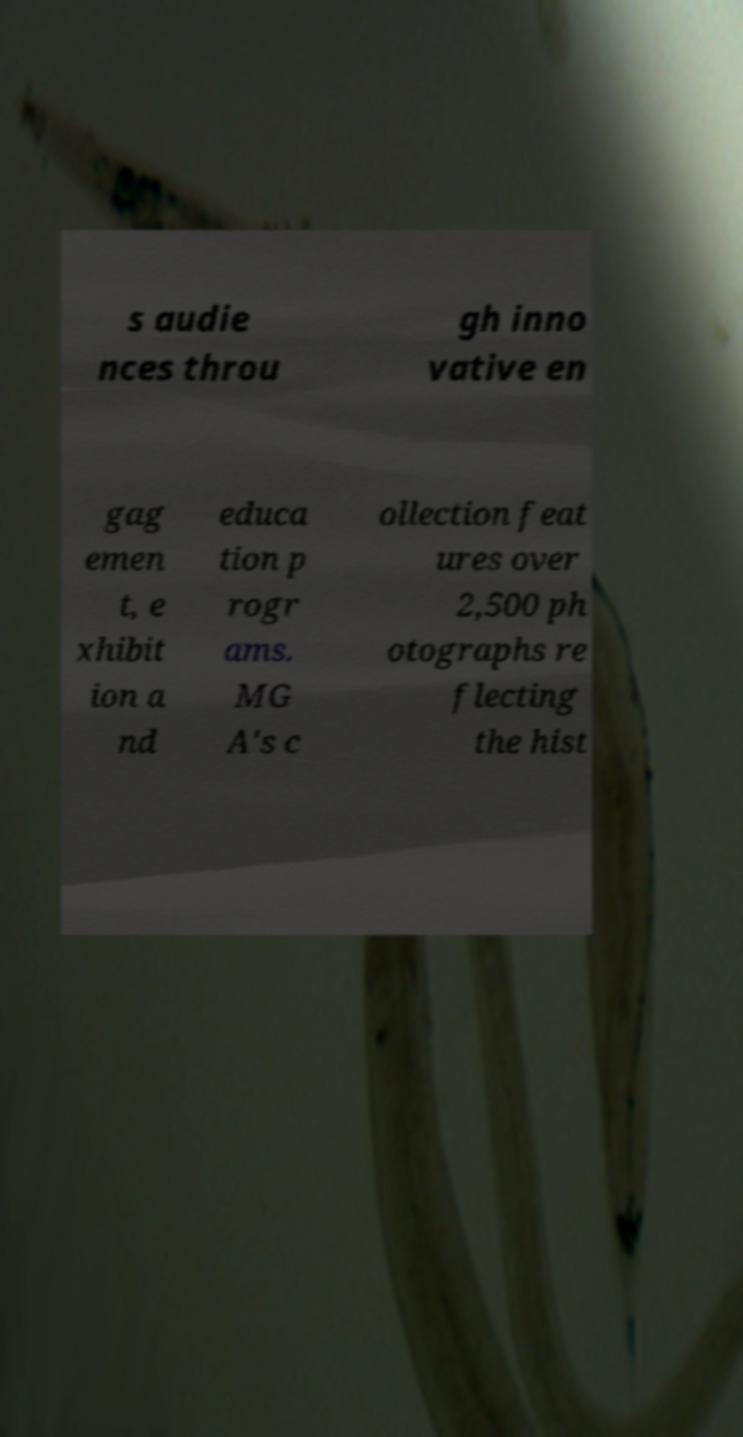There's text embedded in this image that I need extracted. Can you transcribe it verbatim? s audie nces throu gh inno vative en gag emen t, e xhibit ion a nd educa tion p rogr ams. MG A's c ollection feat ures over 2,500 ph otographs re flecting the hist 